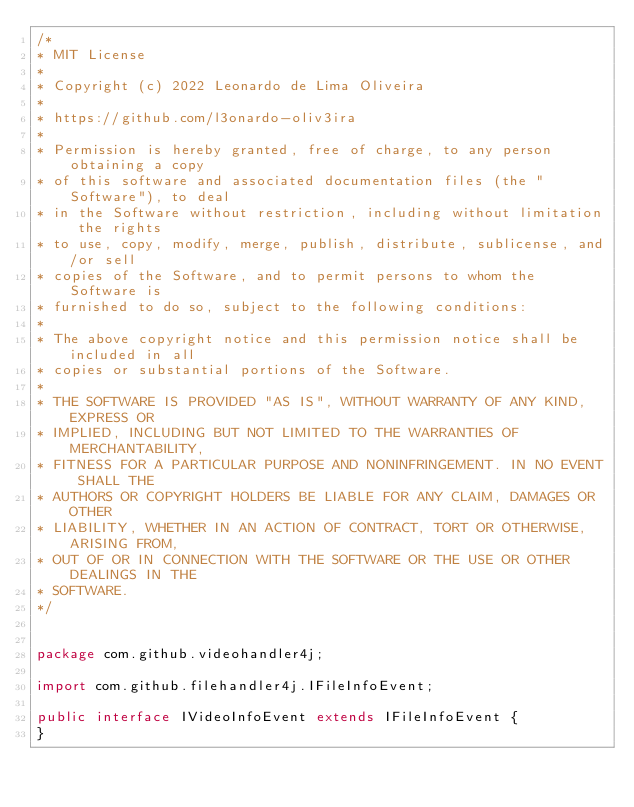<code> <loc_0><loc_0><loc_500><loc_500><_Java_>/*
* MIT License
* 
* Copyright (c) 2022 Leonardo de Lima Oliveira
* 
* https://github.com/l3onardo-oliv3ira
* 
* Permission is hereby granted, free of charge, to any person obtaining a copy
* of this software and associated documentation files (the "Software"), to deal
* in the Software without restriction, including without limitation the rights
* to use, copy, modify, merge, publish, distribute, sublicense, and/or sell
* copies of the Software, and to permit persons to whom the Software is
* furnished to do so, subject to the following conditions:
* 
* The above copyright notice and this permission notice shall be included in all
* copies or substantial portions of the Software.
* 
* THE SOFTWARE IS PROVIDED "AS IS", WITHOUT WARRANTY OF ANY KIND, EXPRESS OR
* IMPLIED, INCLUDING BUT NOT LIMITED TO THE WARRANTIES OF MERCHANTABILITY,
* FITNESS FOR A PARTICULAR PURPOSE AND NONINFRINGEMENT. IN NO EVENT SHALL THE
* AUTHORS OR COPYRIGHT HOLDERS BE LIABLE FOR ANY CLAIM, DAMAGES OR OTHER
* LIABILITY, WHETHER IN AN ACTION OF CONTRACT, TORT OR OTHERWISE, ARISING FROM,
* OUT OF OR IN CONNECTION WITH THE SOFTWARE OR THE USE OR OTHER DEALINGS IN THE
* SOFTWARE.
*/


package com.github.videohandler4j;

import com.github.filehandler4j.IFileInfoEvent;

public interface IVideoInfoEvent extends IFileInfoEvent {
}
</code> 